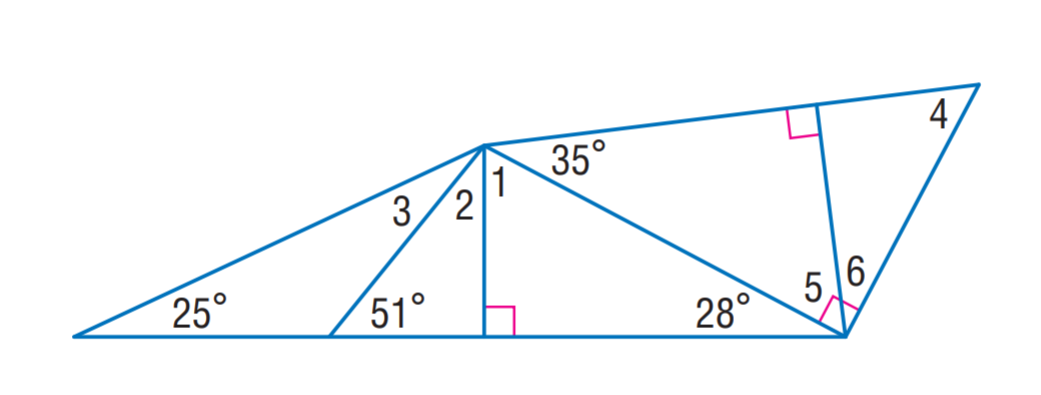Answer the mathemtical geometry problem and directly provide the correct option letter.
Question: Find m \angle 3.
Choices: A: 26 B: 39 C: 55 D: 62 A 